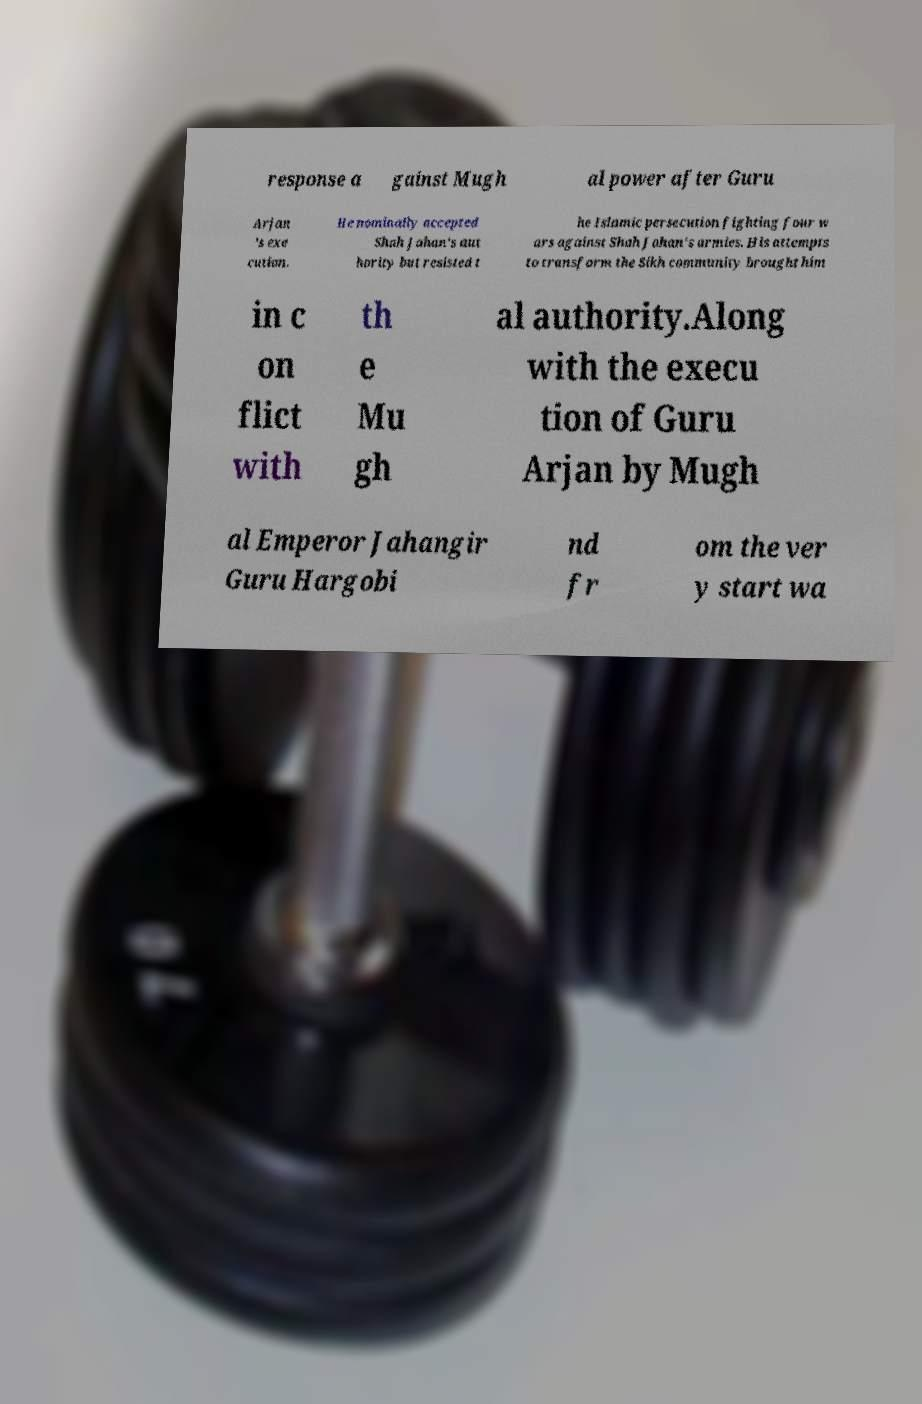I need the written content from this picture converted into text. Can you do that? response a gainst Mugh al power after Guru Arjan 's exe cution. He nominally accepted Shah Jahan's aut hority but resisted t he Islamic persecution fighting four w ars against Shah Jahan's armies. His attempts to transform the Sikh community brought him in c on flict with th e Mu gh al authority.Along with the execu tion of Guru Arjan by Mugh al Emperor Jahangir Guru Hargobi nd fr om the ver y start wa 